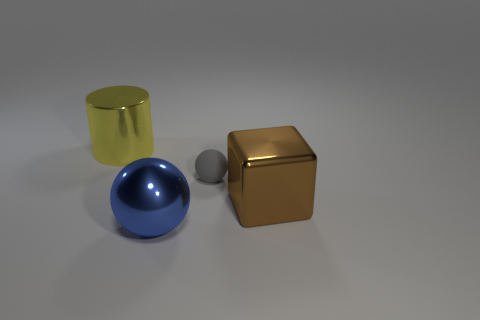What can you tell me about the lighting in this scene? The image has soft lighting, likely from an overhead source, casting subtle shadows beneath the objects, with no harsh reflections, indicating a diffuse light source. 